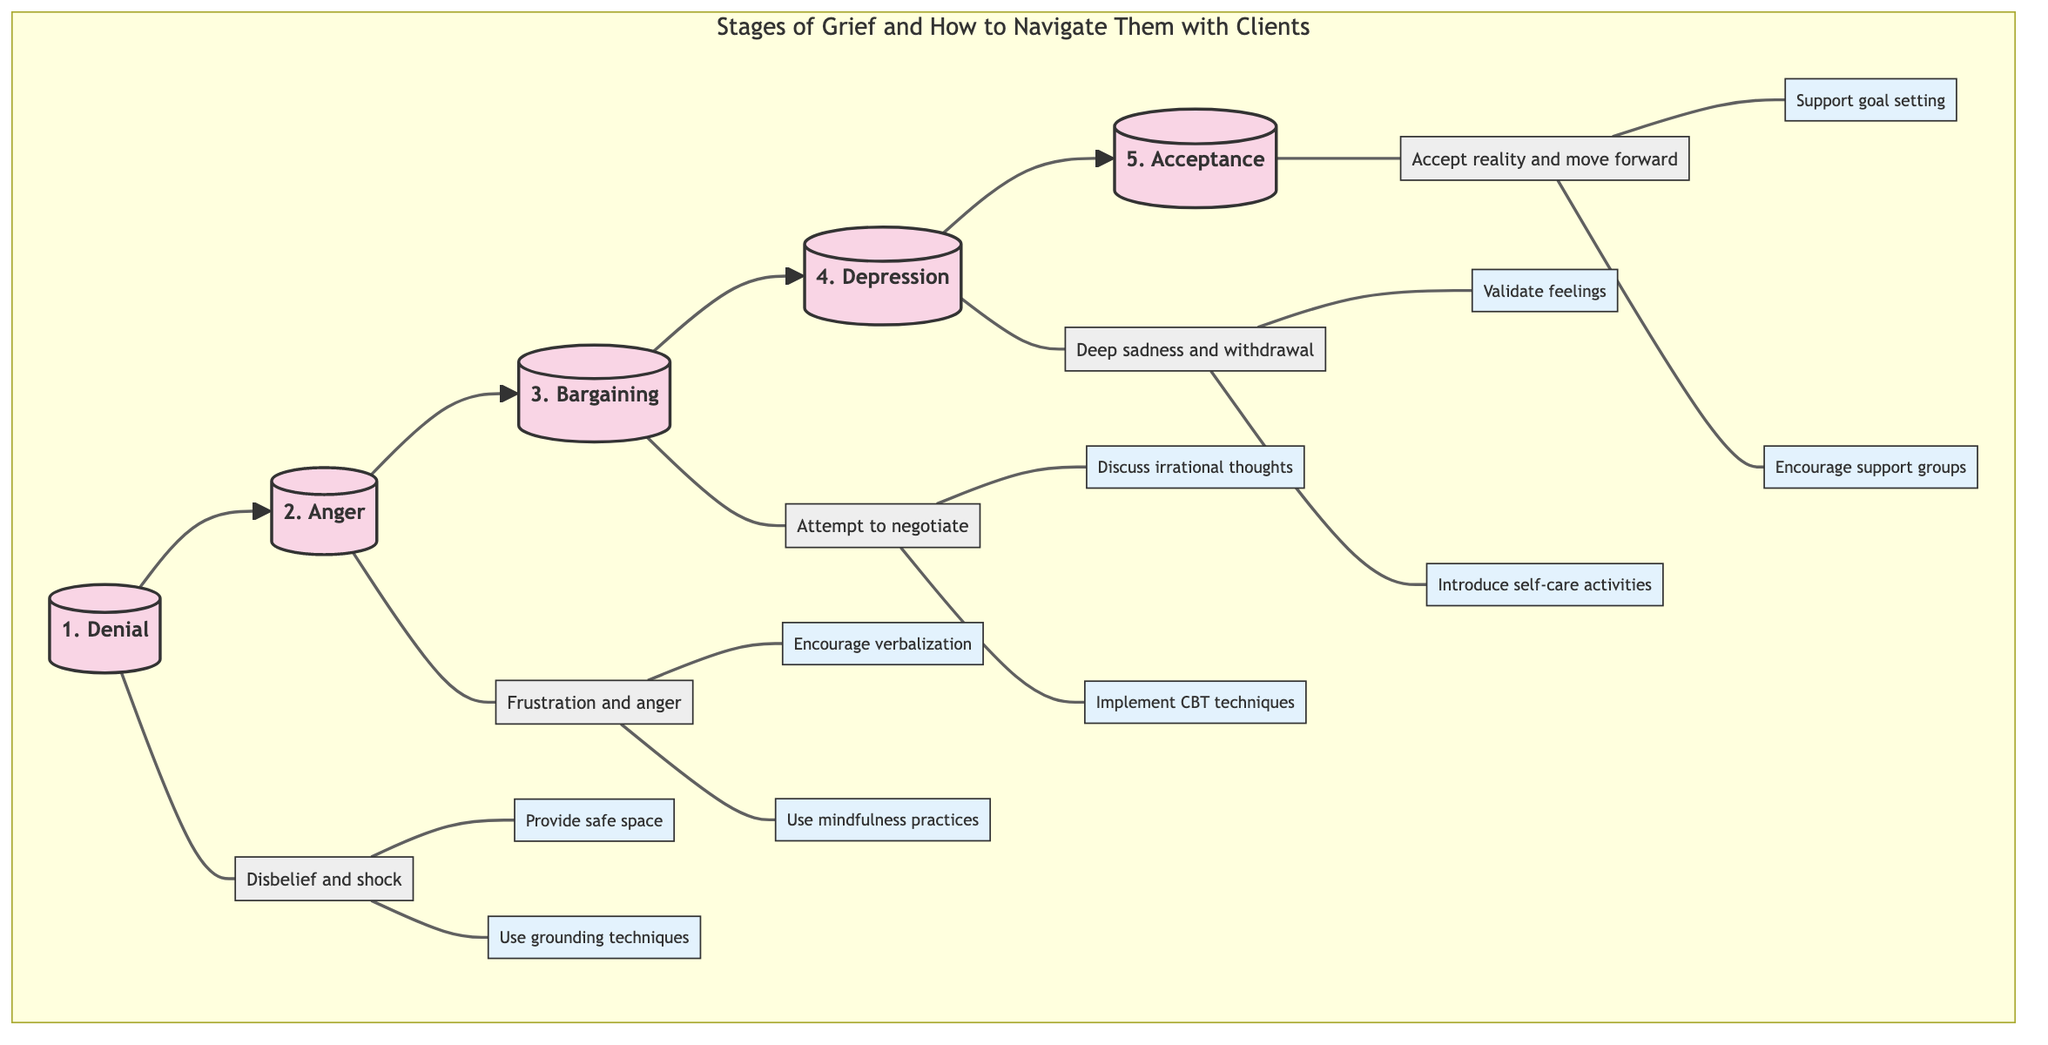What are the stages of grief listed in the diagram? The diagram outlines five stages of grief: Denial, Anger, Bargaining, Depression, and Acceptance.
Answer: Denial, Anger, Bargaining, Depression, Acceptance What is the description for the Depression stage? The description associated with the Depression stage in the diagram states "Clients may experience deep sadness, withdrawal, and hopelessness."
Answer: Deep sadness, withdrawal, and hopelessness How many strategies are provided for the Anger stage? The diagram shows that there are two strategies listed for navigating the Anger stage of grief.
Answer: 2 What is one strategy for the Acceptance stage? The diagram includes multiple strategies for Acceptance, one of which is "Support clients in setting realistic goals for the future."
Answer: Support clients in setting realistic goals for the future Which stage is linked to using mindfulness practices? The Anger stage is linked to using "mindfulness practices" as a strategy to manage intense emotions.
Answer: Anger What follows the Bargaining stage? The diagram indicates that the stage that follows Bargaining is Depression.
Answer: Depression What type of feelings should be validated during the Depression stage? The diagram specifies that "their feelings" should be validated during the Depression stage.
Answer: Their feelings How are the stages organized in the diagram? The stages are organized in a left-to-right flow from Denial to Acceptance in sequential order.
Answer: Left-to-right flow What is the relationship between Denial and Anger in this flowchart? The flowchart illustrates that Denial leads directly to Anger, indicating a progression from one stage to the next.
Answer: Denial leads to Anger 